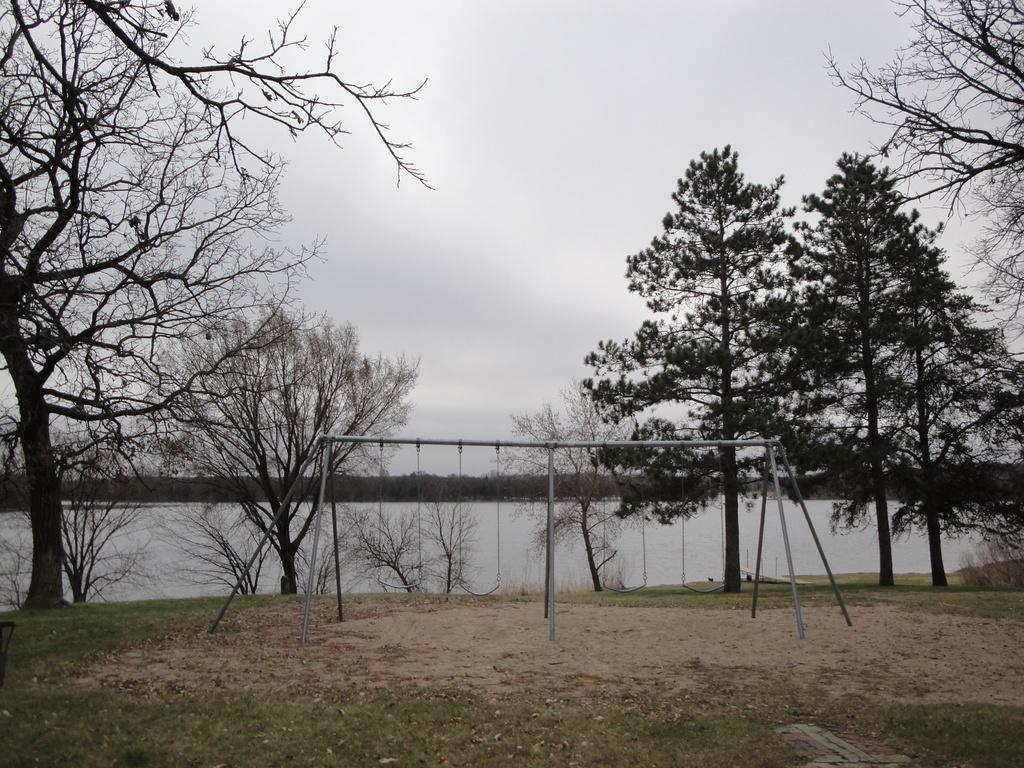What type of playground equipment is present in the image? There are swings in the image. What can be seen behind the swings? There are trees behind the swings. What body of water is visible in the image? There is a river visible in the image. What part of the natural environment is visible in the image? The sky is visible in the image. How many farmers are present in the image? There are no farmers present in the image. What type of boats can be seen sailing on the river in the image? There are no boats visible in the image; only swings, trees, a river, and the sky are present. 